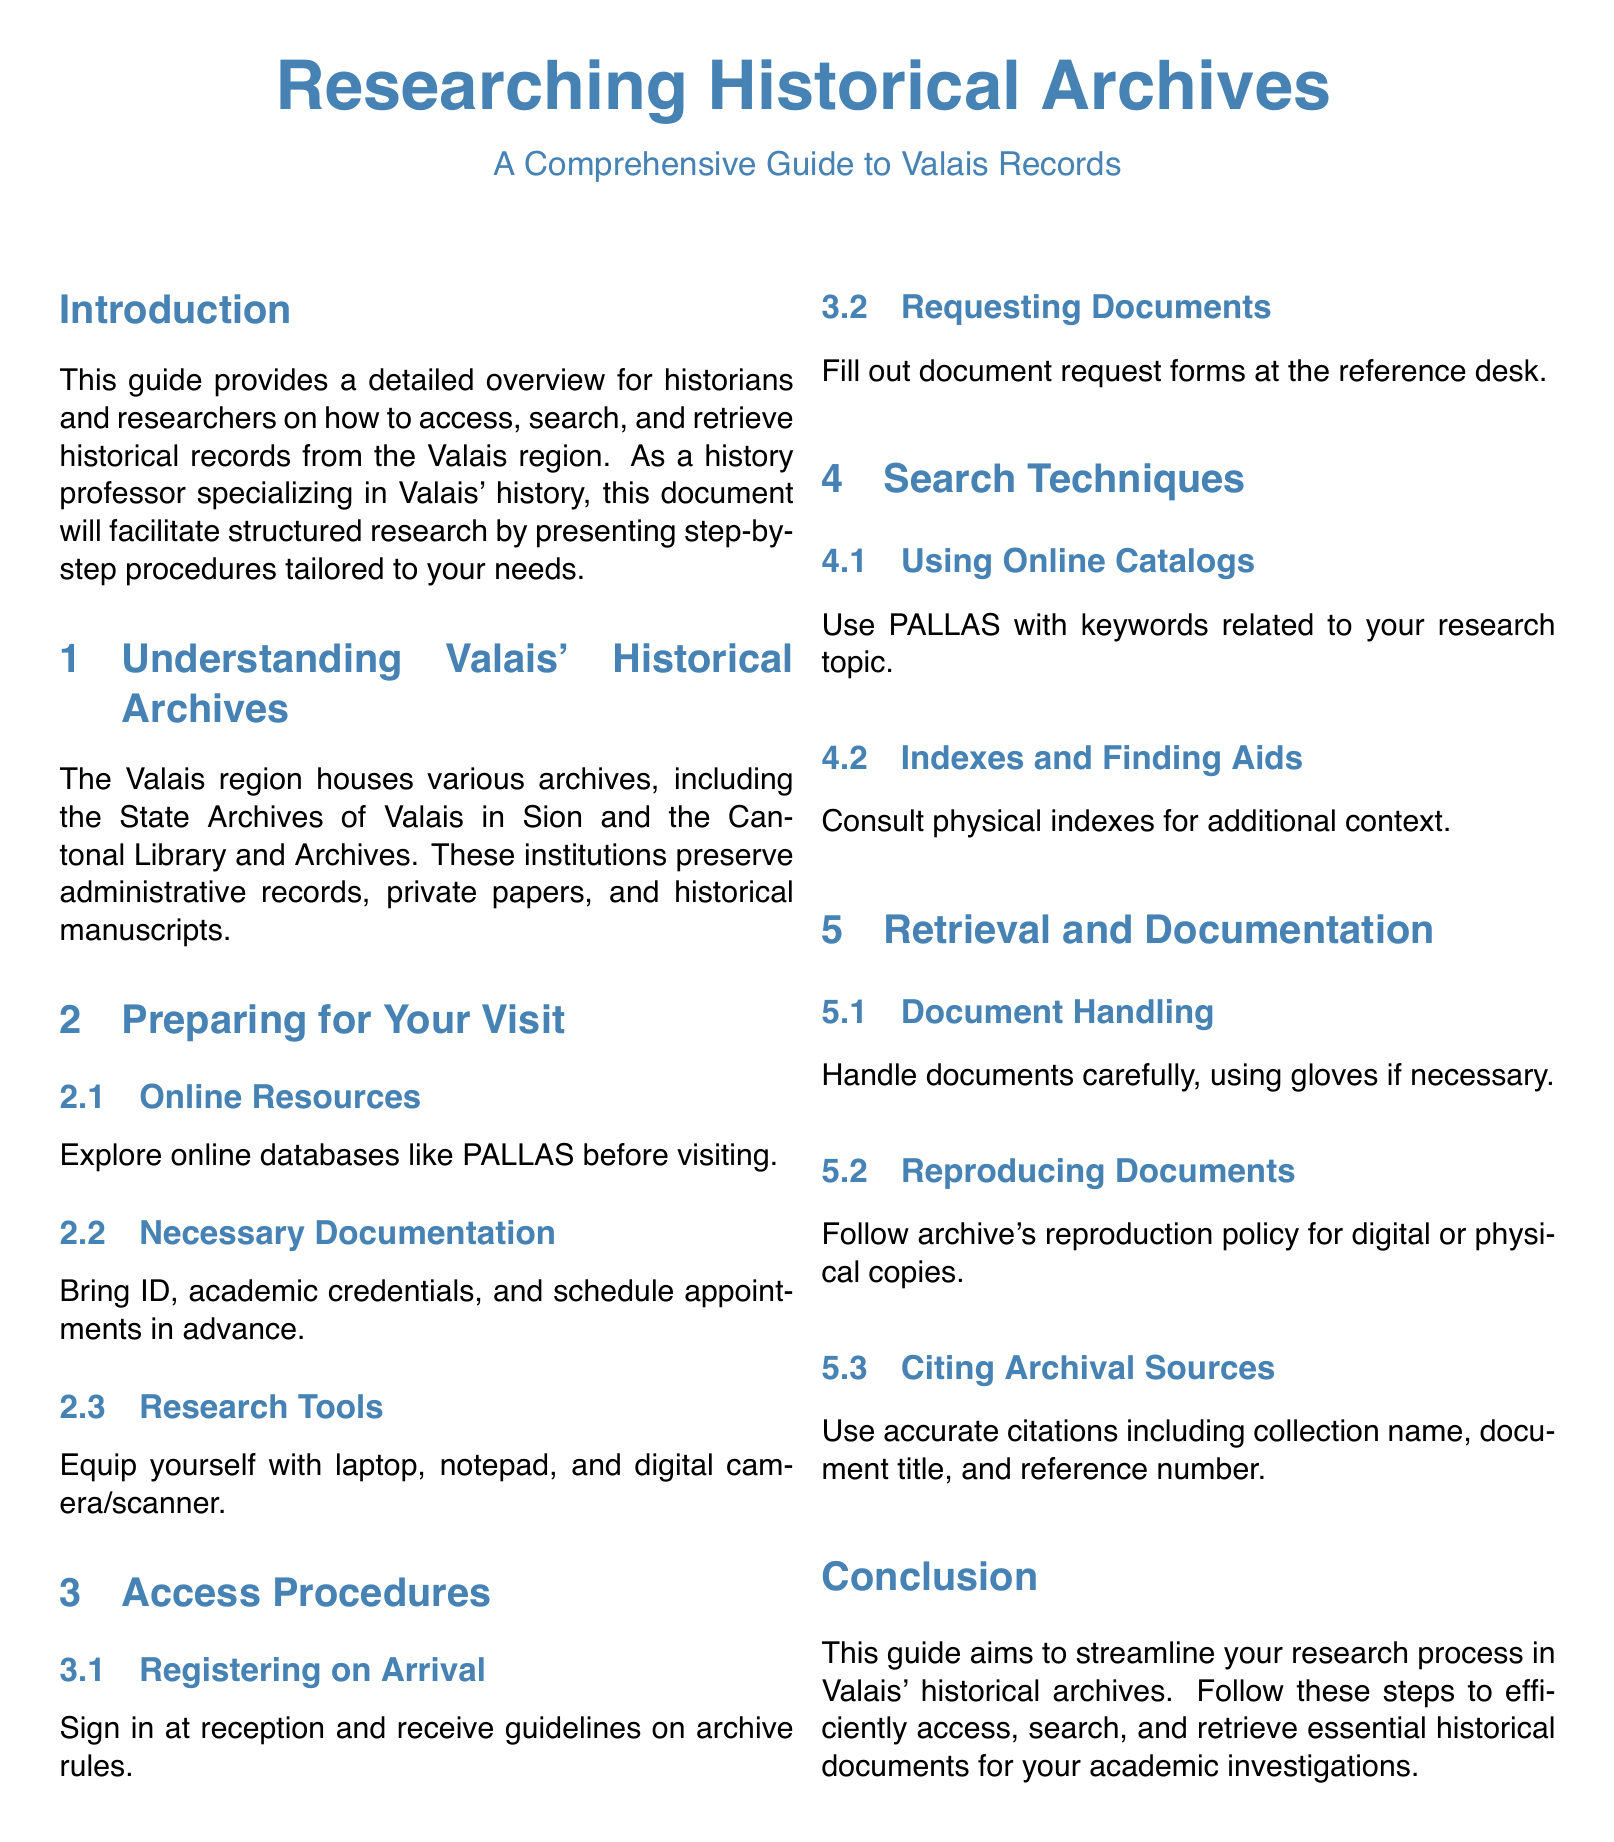What is the main focus of this guide? The main focus is providing an overview for historians and researchers on how to access, search, and retrieve historical records from the Valais region.
Answer: Access, search, and retrieve historical records from the Valais region Where is the State Archives of Valais located? It is located in Sion.
Answer: Sion What online database is recommended before visiting the archives? The guide suggests exploring the online database PALLAS.
Answer: PALLAS What should you bring to the archives? Necessary documentation includes ID, academic credentials, and appointments.
Answer: ID, academic credentials, and appointments What should you use when handling documents? You should handle documents carefully, and gloves may be necessary.
Answer: Gloves What is required for reproducing documents? You need to follow the archive's reproduction policy.
Answer: Archive's reproduction policy List one recommended research tool. A laptop is mentioned as a recommended research tool.
Answer: Laptop What are the first steps upon arrival at the archives? You should sign in at reception and receive guidelines on archive rules.
Answer: Sign in at reception and receive guidelines 